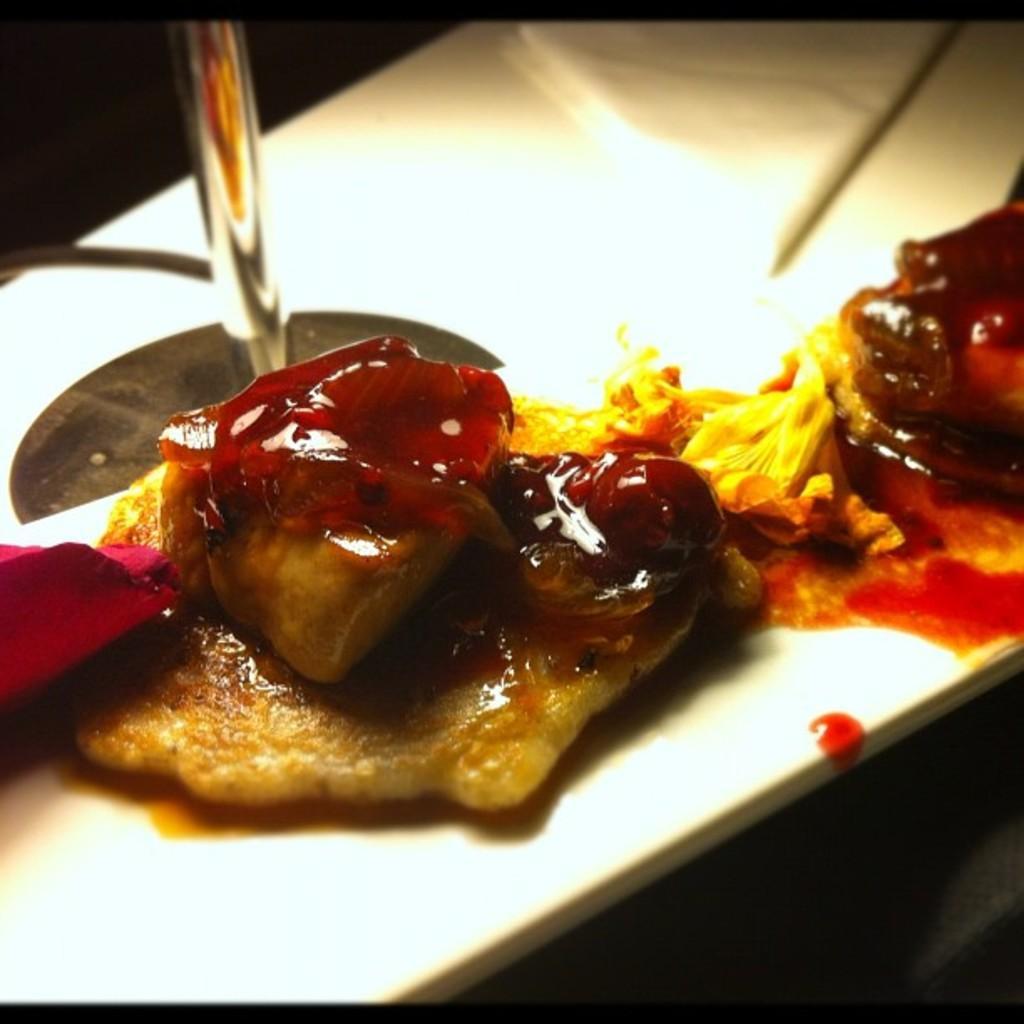Describe this image in one or two sentences. In this image we can see some food in plate placed on the table. 